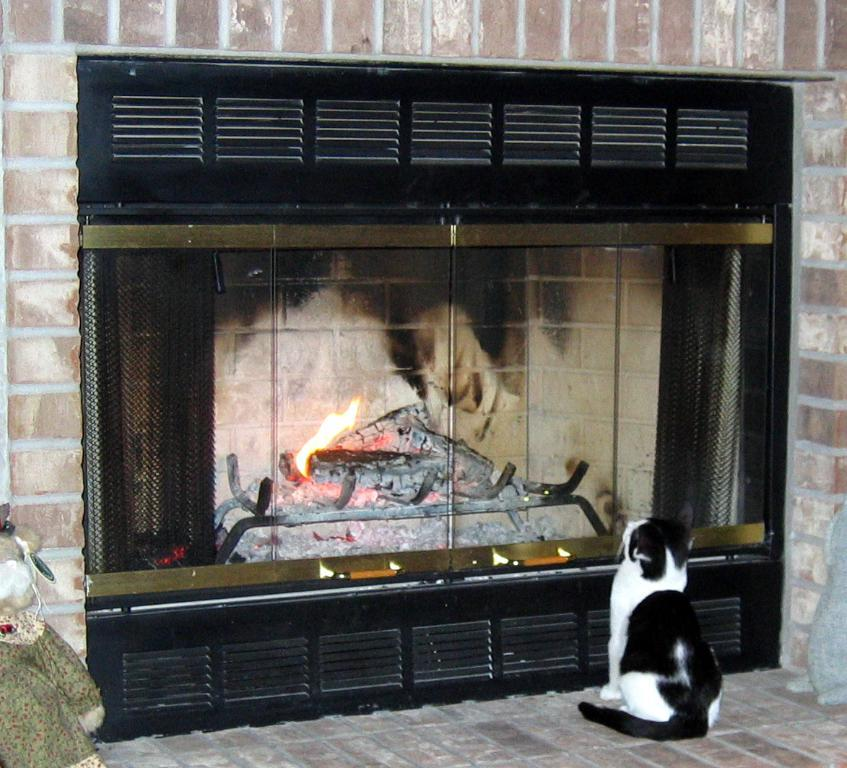What type of animal is in the image? There is a cat in the image. Where is the cat located in the image? The cat is in front of a fireplace. What type of sidewalk can be seen through the window in the image? There is no window or sidewalk present in the image; it features a cat in front of a fireplace. 